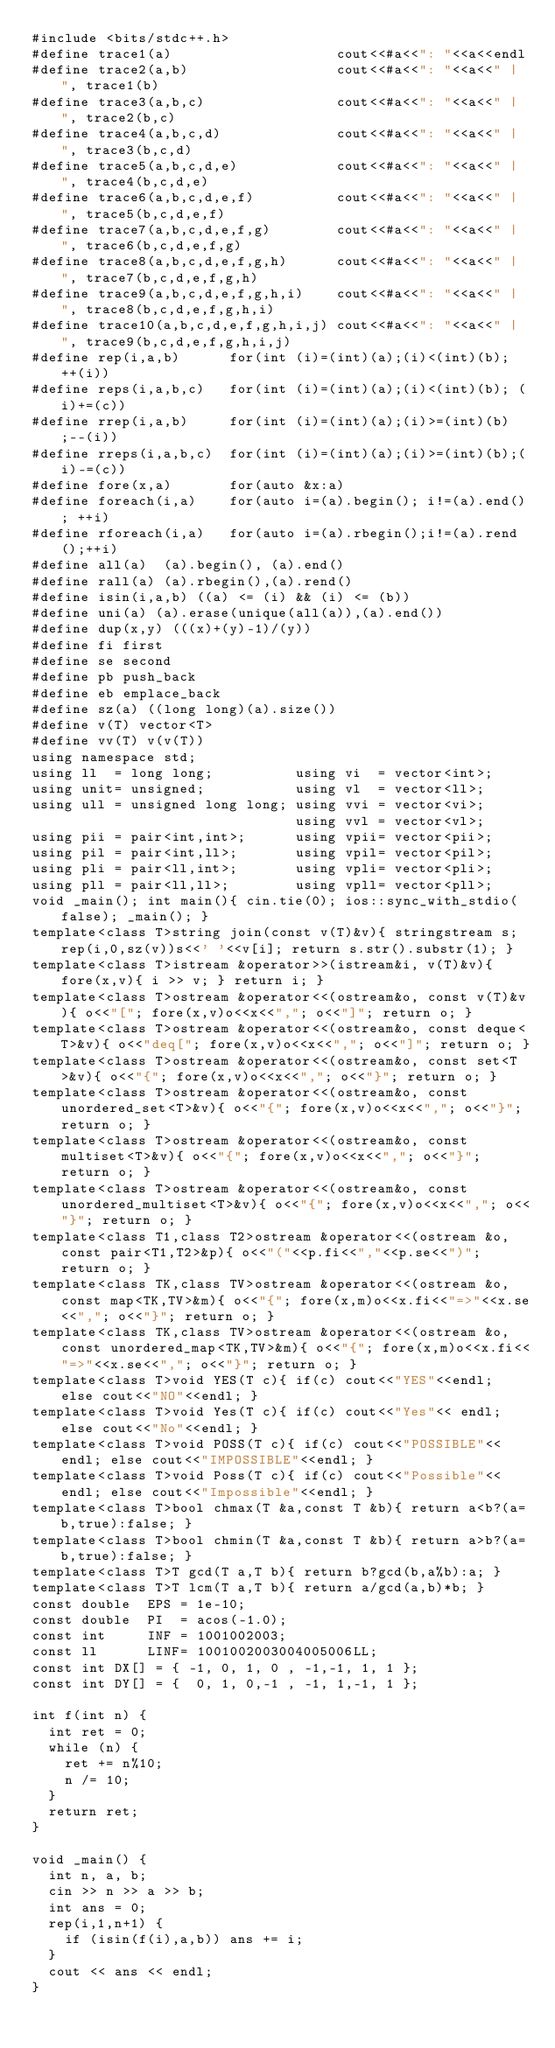Convert code to text. <code><loc_0><loc_0><loc_500><loc_500><_C++_>#include <bits/stdc++.h>
#define trace1(a)                    cout<<#a<<": "<<a<<endl
#define trace2(a,b)                  cout<<#a<<": "<<a<<" | ", trace1(b)
#define trace3(a,b,c)                cout<<#a<<": "<<a<<" | ", trace2(b,c)
#define trace4(a,b,c,d)              cout<<#a<<": "<<a<<" | ", trace3(b,c,d)
#define trace5(a,b,c,d,e)            cout<<#a<<": "<<a<<" | ", trace4(b,c,d,e)
#define trace6(a,b,c,d,e,f)          cout<<#a<<": "<<a<<" | ", trace5(b,c,d,e,f)
#define trace7(a,b,c,d,e,f,g)        cout<<#a<<": "<<a<<" | ", trace6(b,c,d,e,f,g)
#define trace8(a,b,c,d,e,f,g,h)      cout<<#a<<": "<<a<<" | ", trace7(b,c,d,e,f,g,h)
#define trace9(a,b,c,d,e,f,g,h,i)    cout<<#a<<": "<<a<<" | ", trace8(b,c,d,e,f,g,h,i)
#define trace10(a,b,c,d,e,f,g,h,i,j) cout<<#a<<": "<<a<<" | ", trace9(b,c,d,e,f,g,h,i,j)
#define rep(i,a,b)      for(int (i)=(int)(a);(i)<(int)(b); ++(i))
#define reps(i,a,b,c)   for(int (i)=(int)(a);(i)<(int)(b); (i)+=(c))
#define rrep(i,a,b)     for(int (i)=(int)(a);(i)>=(int)(b);--(i))
#define rreps(i,a,b,c)  for(int (i)=(int)(a);(i)>=(int)(b);(i)-=(c))
#define fore(x,a)       for(auto &x:a)
#define foreach(i,a)    for(auto i=(a).begin(); i!=(a).end(); ++i)
#define rforeach(i,a)   for(auto i=(a).rbegin();i!=(a).rend();++i)
#define all(a)  (a).begin(), (a).end()
#define rall(a) (a).rbegin(),(a).rend()
#define isin(i,a,b) ((a) <= (i) && (i) <= (b))
#define uni(a) (a).erase(unique(all(a)),(a).end())
#define dup(x,y) (((x)+(y)-1)/(y))
#define fi first
#define se second
#define pb push_back
#define eb emplace_back
#define sz(a) ((long long)(a).size())
#define v(T) vector<T>
#define vv(T) v(v(T))
using namespace std;
using ll  = long long;          using vi  = vector<int>;
using unit= unsigned;           using vl  = vector<ll>;
using ull = unsigned long long; using vvi = vector<vi>;
                                using vvl = vector<vl>;
using pii = pair<int,int>;      using vpii= vector<pii>;
using pil = pair<int,ll>;       using vpil= vector<pil>;
using pli = pair<ll,int>;       using vpli= vector<pli>;
using pll = pair<ll,ll>;        using vpll= vector<pll>;
void _main(); int main(){ cin.tie(0); ios::sync_with_stdio(false); _main(); }
template<class T>string join(const v(T)&v){ stringstream s; rep(i,0,sz(v))s<<' '<<v[i]; return s.str().substr(1); }
template<class T>istream &operator>>(istream&i, v(T)&v){ fore(x,v){ i >> v; } return i; }
template<class T>ostream &operator<<(ostream&o, const v(T)&v){ o<<"["; fore(x,v)o<<x<<","; o<<"]"; return o; }
template<class T>ostream &operator<<(ostream&o, const deque<T>&v){ o<<"deq["; fore(x,v)o<<x<<","; o<<"]"; return o; }
template<class T>ostream &operator<<(ostream&o, const set<T>&v){ o<<"{"; fore(x,v)o<<x<<","; o<<"}"; return o; }
template<class T>ostream &operator<<(ostream&o, const unordered_set<T>&v){ o<<"{"; fore(x,v)o<<x<<","; o<<"}"; return o; }
template<class T>ostream &operator<<(ostream&o, const multiset<T>&v){ o<<"{"; fore(x,v)o<<x<<","; o<<"}"; return o; }
template<class T>ostream &operator<<(ostream&o, const unordered_multiset<T>&v){ o<<"{"; fore(x,v)o<<x<<","; o<<"}"; return o; }
template<class T1,class T2>ostream &operator<<(ostream &o, const pair<T1,T2>&p){ o<<"("<<p.fi<<","<<p.se<<")"; return o; }
template<class TK,class TV>ostream &operator<<(ostream &o, const map<TK,TV>&m){ o<<"{"; fore(x,m)o<<x.fi<<"=>"<<x.se<<","; o<<"}"; return o; }
template<class TK,class TV>ostream &operator<<(ostream &o, const unordered_map<TK,TV>&m){ o<<"{"; fore(x,m)o<<x.fi<<"=>"<<x.se<<","; o<<"}"; return o; }
template<class T>void YES(T c){ if(c) cout<<"YES"<<endl; else cout<<"NO"<<endl; }
template<class T>void Yes(T c){ if(c) cout<<"Yes"<< endl; else cout<<"No"<<endl; }
template<class T>void POSS(T c){ if(c) cout<<"POSSIBLE"<<endl; else cout<<"IMPOSSIBLE"<<endl; }
template<class T>void Poss(T c){ if(c) cout<<"Possible"<<endl; else cout<<"Impossible"<<endl; }
template<class T>bool chmax(T &a,const T &b){ return a<b?(a=b,true):false; }
template<class T>bool chmin(T &a,const T &b){ return a>b?(a=b,true):false; }
template<class T>T gcd(T a,T b){ return b?gcd(b,a%b):a; }
template<class T>T lcm(T a,T b){ return a/gcd(a,b)*b; }
const double  EPS = 1e-10;
const double  PI  = acos(-1.0);
const int     INF = 1001002003;
const ll      LINF= 1001002003004005006LL;
const int DX[] = { -1, 0, 1, 0 , -1,-1, 1, 1 };
const int DY[] = {  0, 1, 0,-1 , -1, 1,-1, 1 };

int f(int n) {
  int ret = 0;
  while (n) {
    ret += n%10;
    n /= 10;
  }
  return ret;
}

void _main() {
  int n, a, b;
  cin >> n >> a >> b;
  int ans = 0;
  rep(i,1,n+1) {
    if (isin(f(i),a,b)) ans += i;
  }
  cout << ans << endl;
}
</code> 